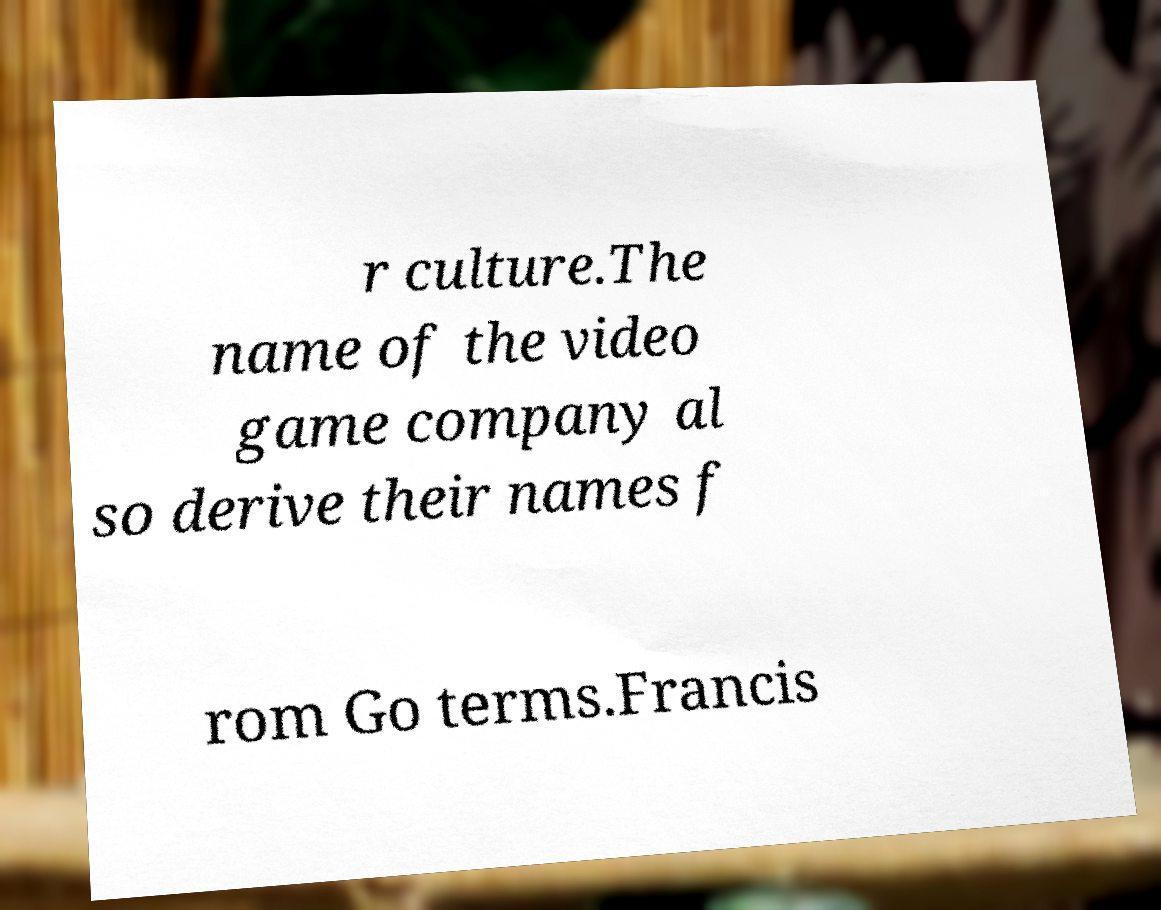There's text embedded in this image that I need extracted. Can you transcribe it verbatim? r culture.The name of the video game company al so derive their names f rom Go terms.Francis 